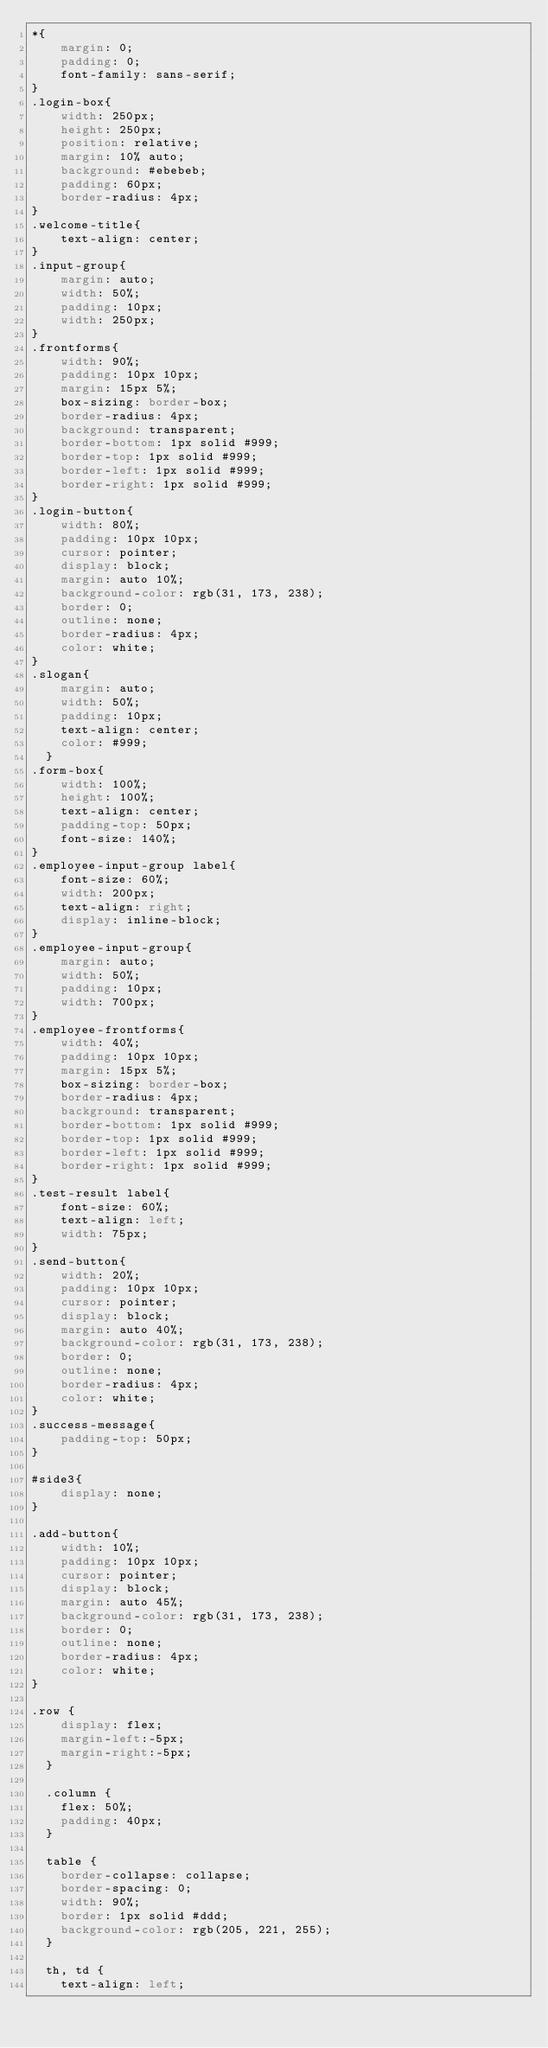Convert code to text. <code><loc_0><loc_0><loc_500><loc_500><_CSS_>*{
    margin: 0;
    padding: 0;
    font-family: sans-serif;
}
.login-box{
    width: 250px;
    height: 250px;
    position: relative;
    margin: 10% auto;
    background: #ebebeb;
    padding: 60px;
    border-radius: 4px;
}
.welcome-title{
    text-align: center;
}
.input-group{
    margin: auto;
    width: 50%;
    padding: 10px;
    width: 250px;
}
.frontforms{
    width: 90%;
    padding: 10px 10px;
    margin: 15px 5%;
    box-sizing: border-box;
    border-radius: 4px;
    background: transparent;
    border-bottom: 1px solid #999;
    border-top: 1px solid #999;
    border-left: 1px solid #999;
    border-right: 1px solid #999;
}
.login-button{
    width: 80%;
    padding: 10px 10px;
    cursor: pointer;
    display: block;
    margin: auto 10%;
    background-color: rgb(31, 173, 238);
    border: 0;
    outline: none;
    border-radius: 4px;
    color: white;
}
.slogan{
    margin: auto;
    width: 50%;
    padding: 10px;
    text-align: center;
    color: #999;
  }
.form-box{
    width: 100%;
    height: 100%;
    text-align: center;
    padding-top: 50px;
    font-size: 140%;
}
.employee-input-group label{
    font-size: 60%;
    width: 200px;
    text-align: right;
    display: inline-block;
}
.employee-input-group{
    margin: auto;
    width: 50%;
    padding: 10px;
    width: 700px;
}
.employee-frontforms{
    width: 40%;
    padding: 10px 10px;
    margin: 15px 5%;
    box-sizing: border-box;
    border-radius: 4px;
    background: transparent;
    border-bottom: 1px solid #999;
    border-top: 1px solid #999;
    border-left: 1px solid #999;
    border-right: 1px solid #999;
}
.test-result label{
    font-size: 60%;
    text-align: left;
    width: 75px;
}
.send-button{
    width: 20%;
    padding: 10px 10px;
    cursor: pointer;
    display: block;
    margin: auto 40%;
    background-color: rgb(31, 173, 238);
    border: 0;
    outline: none;
    border-radius: 4px;
    color: white;
}
.success-message{
    padding-top: 50px;
}

#side3{
    display: none;
}

.add-button{
    width: 10%;
    padding: 10px 10px;
    cursor: pointer;
    display: block;
    margin: auto 45%;
    background-color: rgb(31, 173, 238);
    border: 0;
    outline: none;
    border-radius: 4px;
    color: white;
}

.row {
    display: flex;
    margin-left:-5px;
    margin-right:-5px;
  }
  
  .column {
    flex: 50%;
    padding: 40px;
  }
  
  table {
    border-collapse: collapse;
    border-spacing: 0;
    width: 90%;
    border: 1px solid #ddd;
    background-color: rgb(205, 221, 255);
  }
  
  th, td {
    text-align: left;</code> 